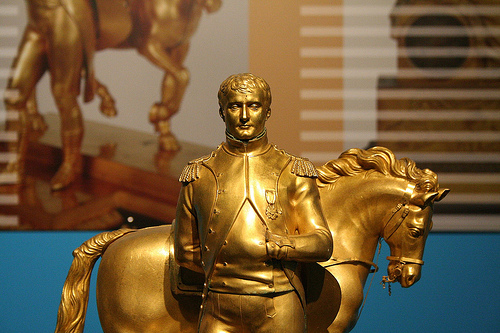<image>
Is the man in front of the horse? Yes. The man is positioned in front of the horse, appearing closer to the camera viewpoint. 